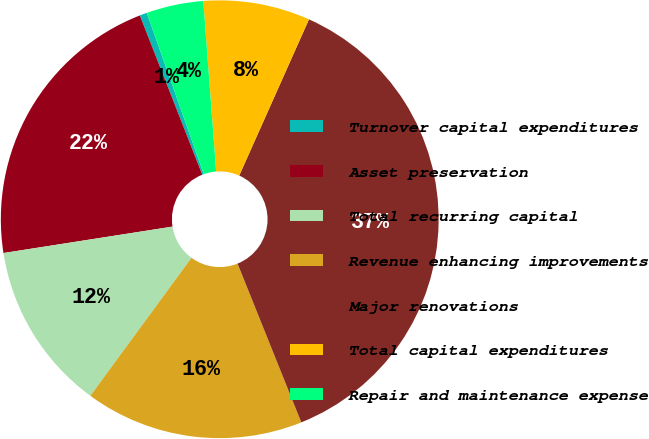<chart> <loc_0><loc_0><loc_500><loc_500><pie_chart><fcel>Turnover capital expenditures<fcel>Asset preservation<fcel>Total recurring capital<fcel>Revenue enhancing improvements<fcel>Major renovations<fcel>Total capital expenditures<fcel>Repair and maintenance expense<nl><fcel>0.54%<fcel>21.52%<fcel>12.47%<fcel>16.14%<fcel>37.24%<fcel>7.88%<fcel>4.21%<nl></chart> 